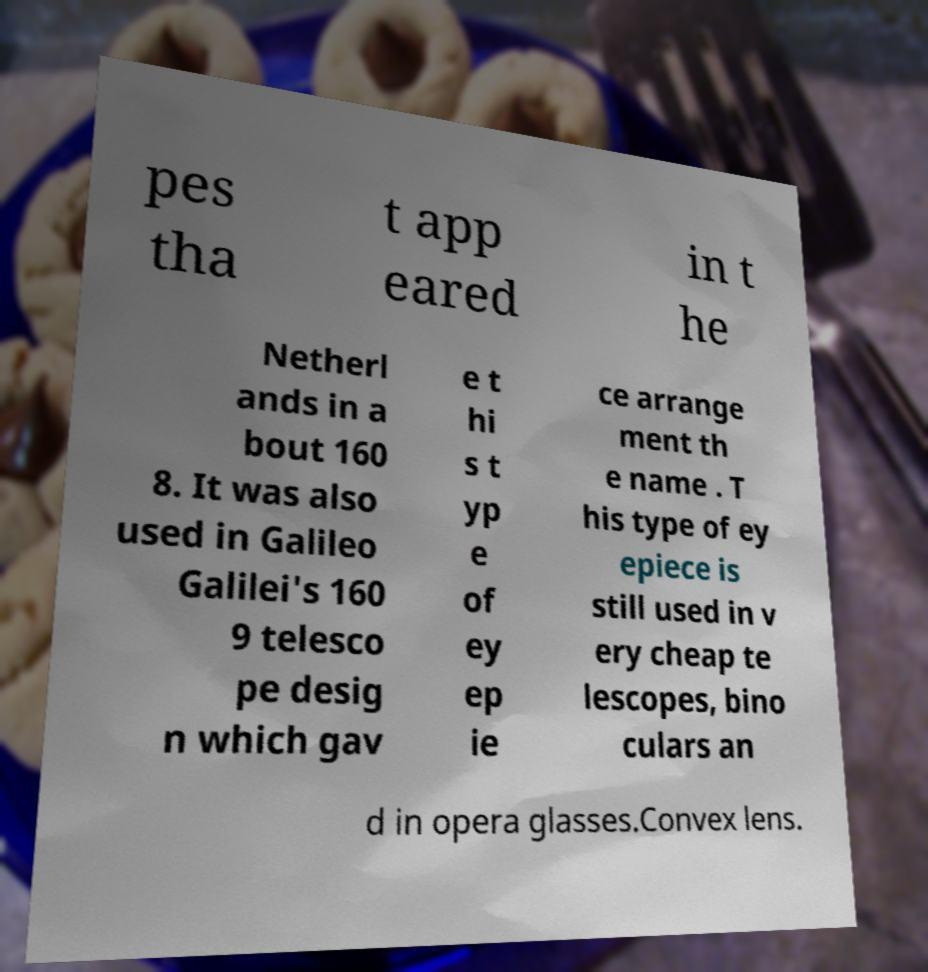Can you accurately transcribe the text from the provided image for me? pes tha t app eared in t he Netherl ands in a bout 160 8. It was also used in Galileo Galilei's 160 9 telesco pe desig n which gav e t hi s t yp e of ey ep ie ce arrange ment th e name . T his type of ey epiece is still used in v ery cheap te lescopes, bino culars an d in opera glasses.Convex lens. 